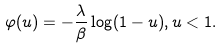<formula> <loc_0><loc_0><loc_500><loc_500>\varphi ( u ) = - \frac { \lambda } { \beta } \log ( 1 - u ) , u < 1 .</formula> 